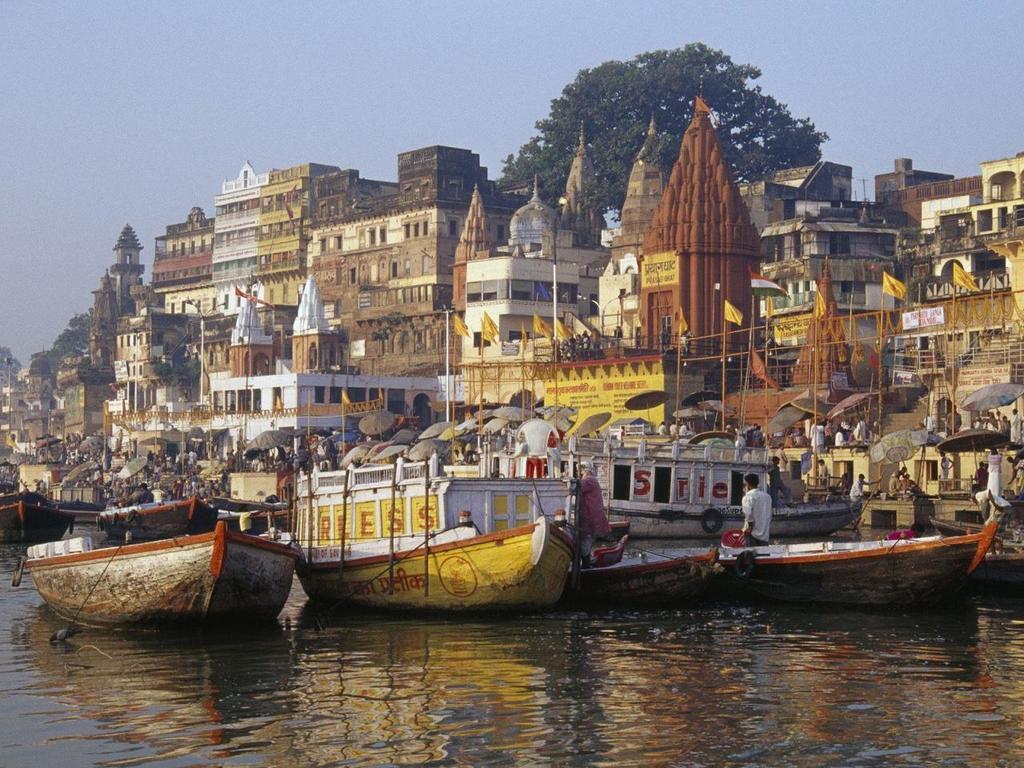Can you describe this image briefly? There are many boats in the water. In the back there are flags with poles, umbrellas. There are many people. Also there are many buildings, trees and sky in the background. 